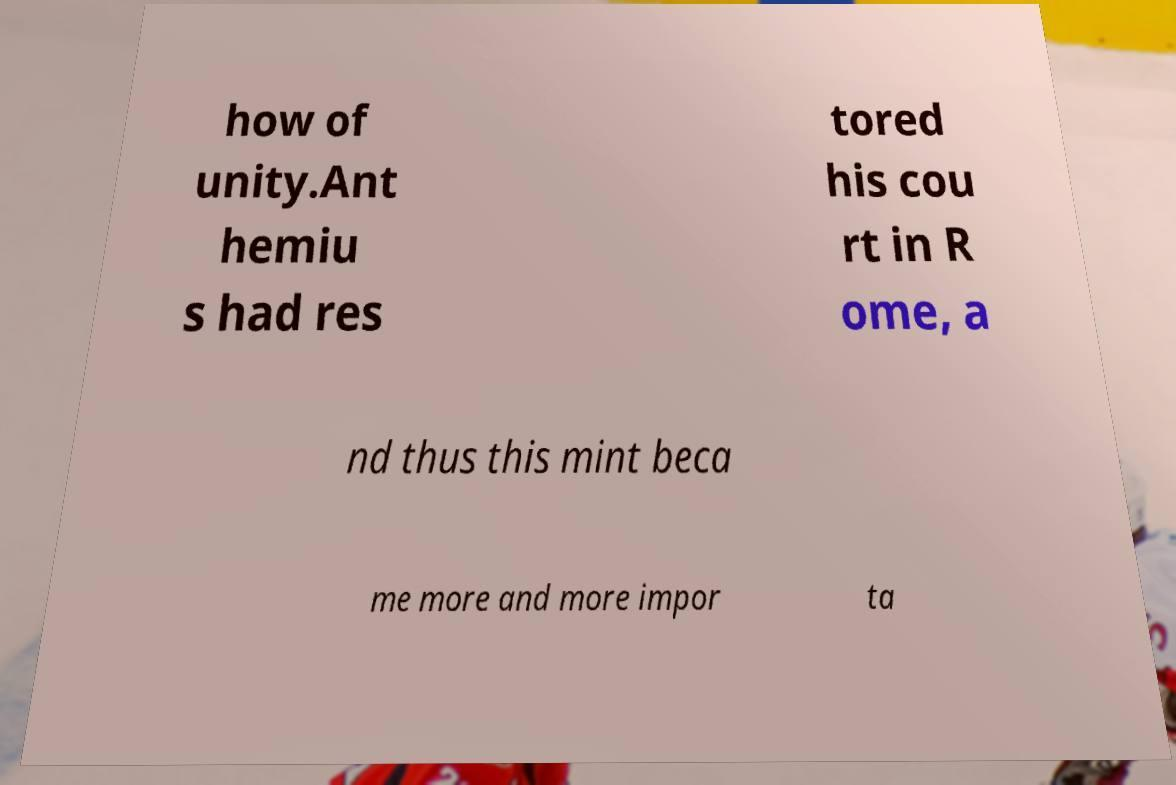Could you assist in decoding the text presented in this image and type it out clearly? how of unity.Ant hemiu s had res tored his cou rt in R ome, a nd thus this mint beca me more and more impor ta 